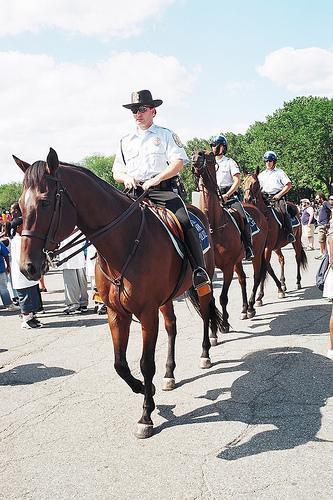How many horses are there?
Give a very brief answer. 3. 